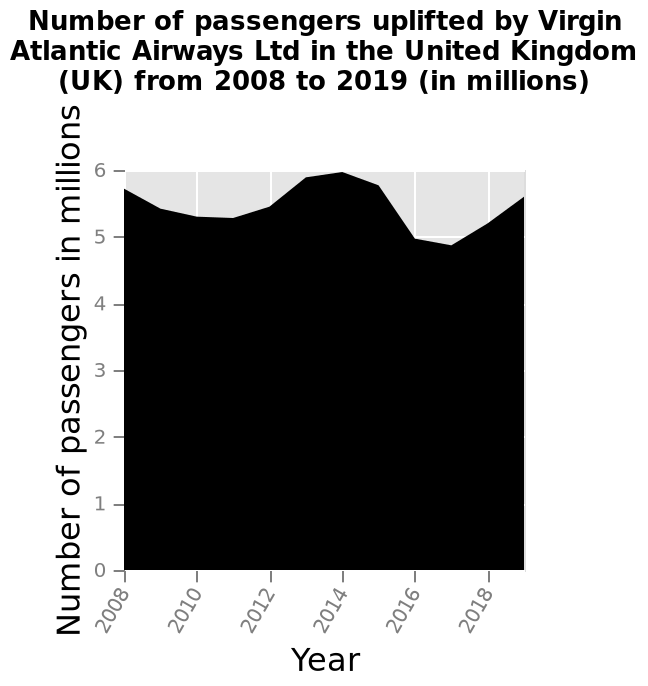<image>
What is the maximum year shown on the x-axis? The maximum year shown on the x-axis is 2018. 